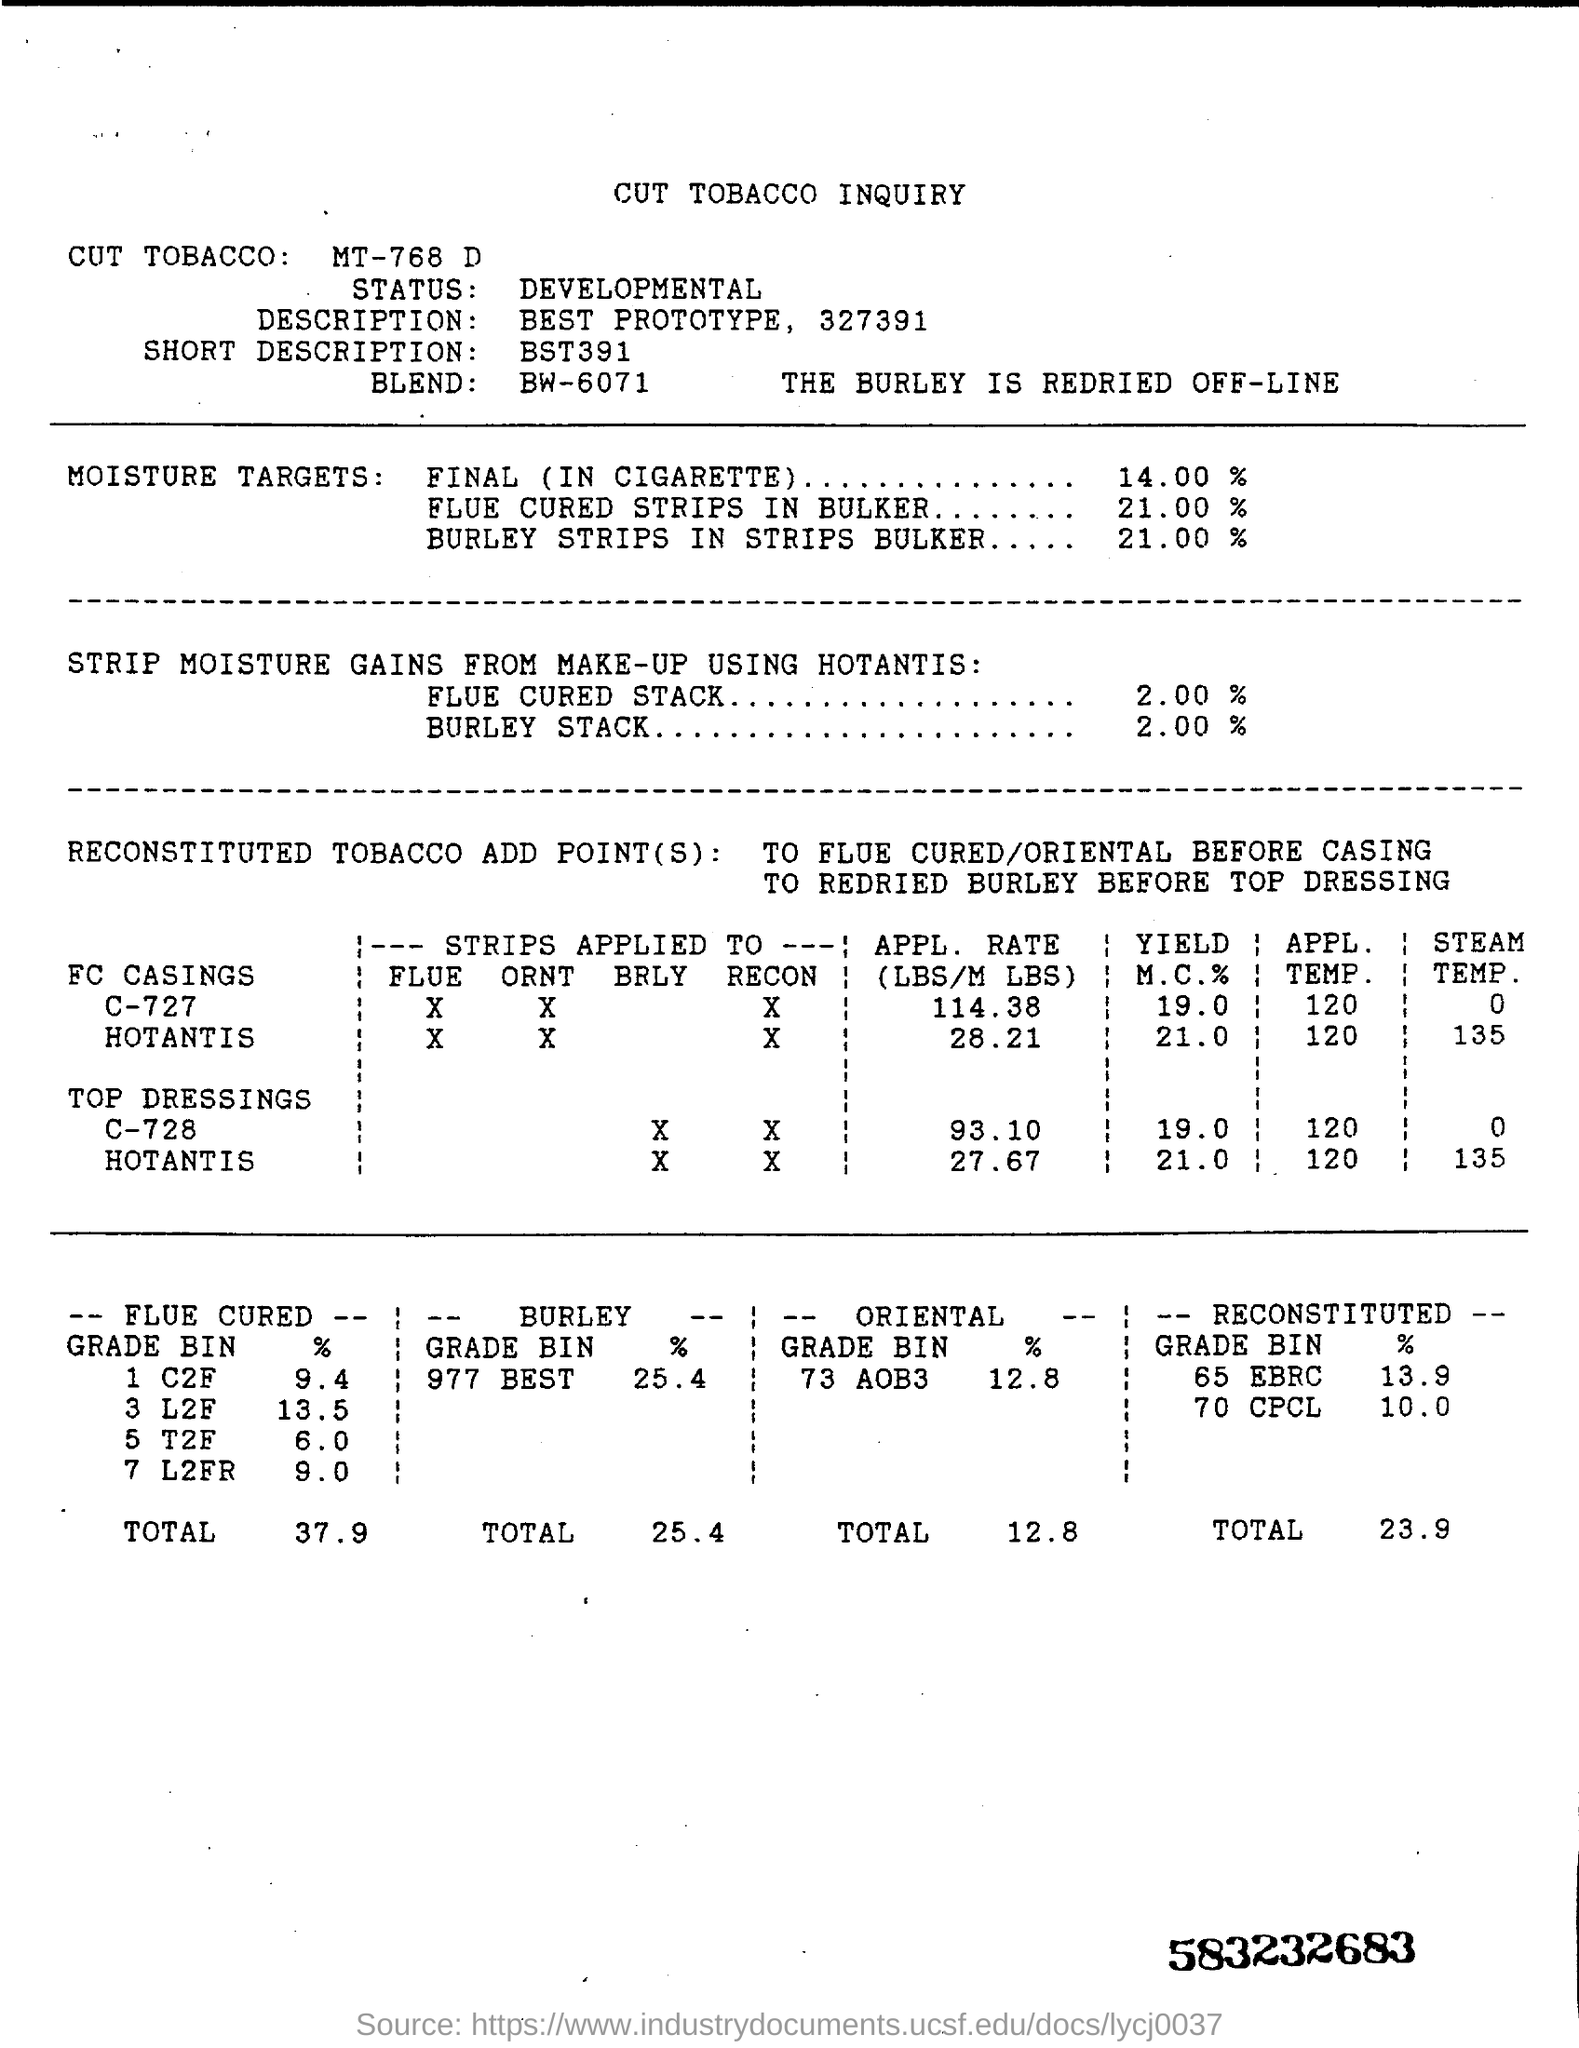What is the 'title' written on the top of the document?
Offer a terse response. CUT TOBACCO INQUIRY. What is the percentage of moisture targets in cigarette?
Provide a short and direct response. 14.00 %. What is the percentage of moisture targets in flue cured strips in bulker?
Ensure brevity in your answer.  21.00 %. What is the 'Status' of this document ?
Keep it short and to the point. Developmental. What is the 'description' of this document?
Give a very brief answer. Best prototype, 327391. What is the 'Short description' of this document?
Your answer should be very brief. Bst391. What is the total percentage of 'flue cured' which is written in the bottom of the document?
Give a very brief answer. 37.9. 